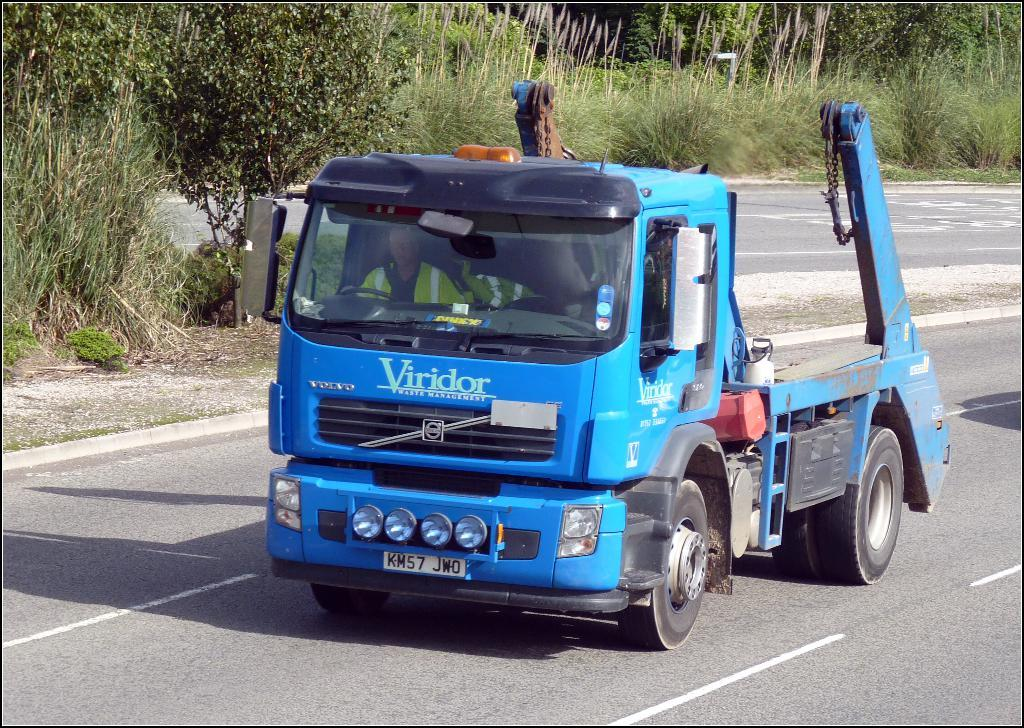What is the main subject of the image? The main subject of the image is a truck. Can you describe the color of the truck? The truck is blue. What is visible at the bottom of the image? There is a road at the bottom of the image. What can be seen in the background of the image? There are trees and plants in the background of the image. What is the truck's desire in the image? Trucks do not have desires, as they are inanimate objects. How many legs can be seen supporting the truck in the image? Trucks do not have legs; they have wheels for support. 